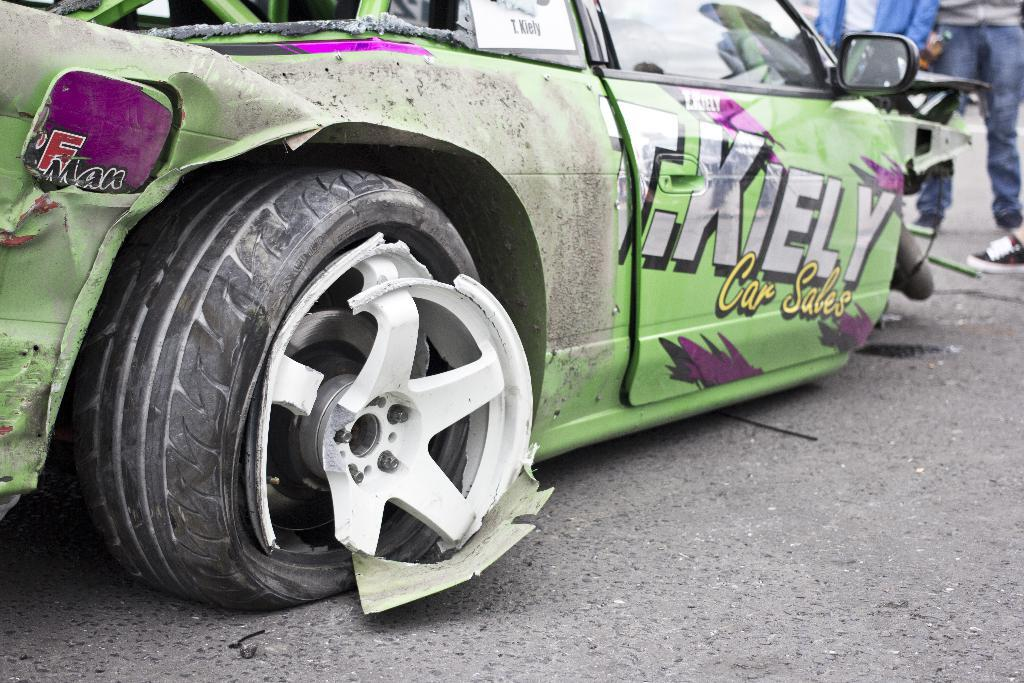What is the main subject of the image? The main subject of the image is a car on the road. Can you describe the person in the image? There is a person standing on the right side of the road. What is the condition of the car's tire in the image? The rim of the tire on the left side of the car is broken. What type of seed is being planted by the governor on the rail in the image? There is no governor, seed, or rail present in the image. 